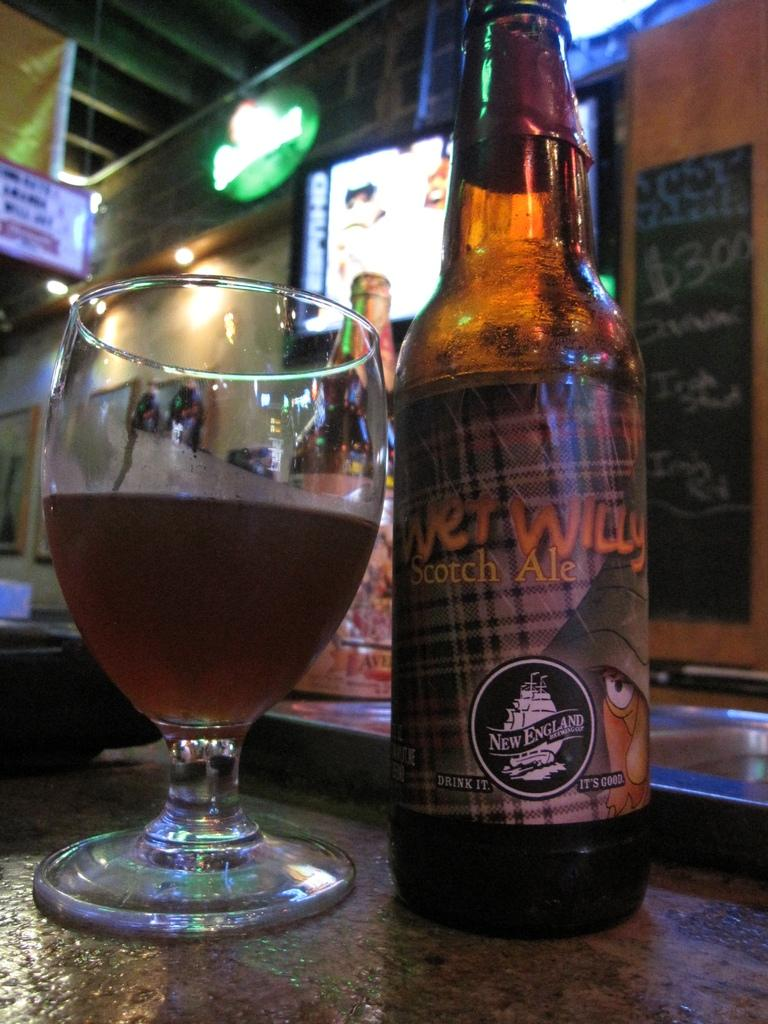<image>
Create a compact narrative representing the image presented. Bottle of Wet Willy Scotch Ale from New England 